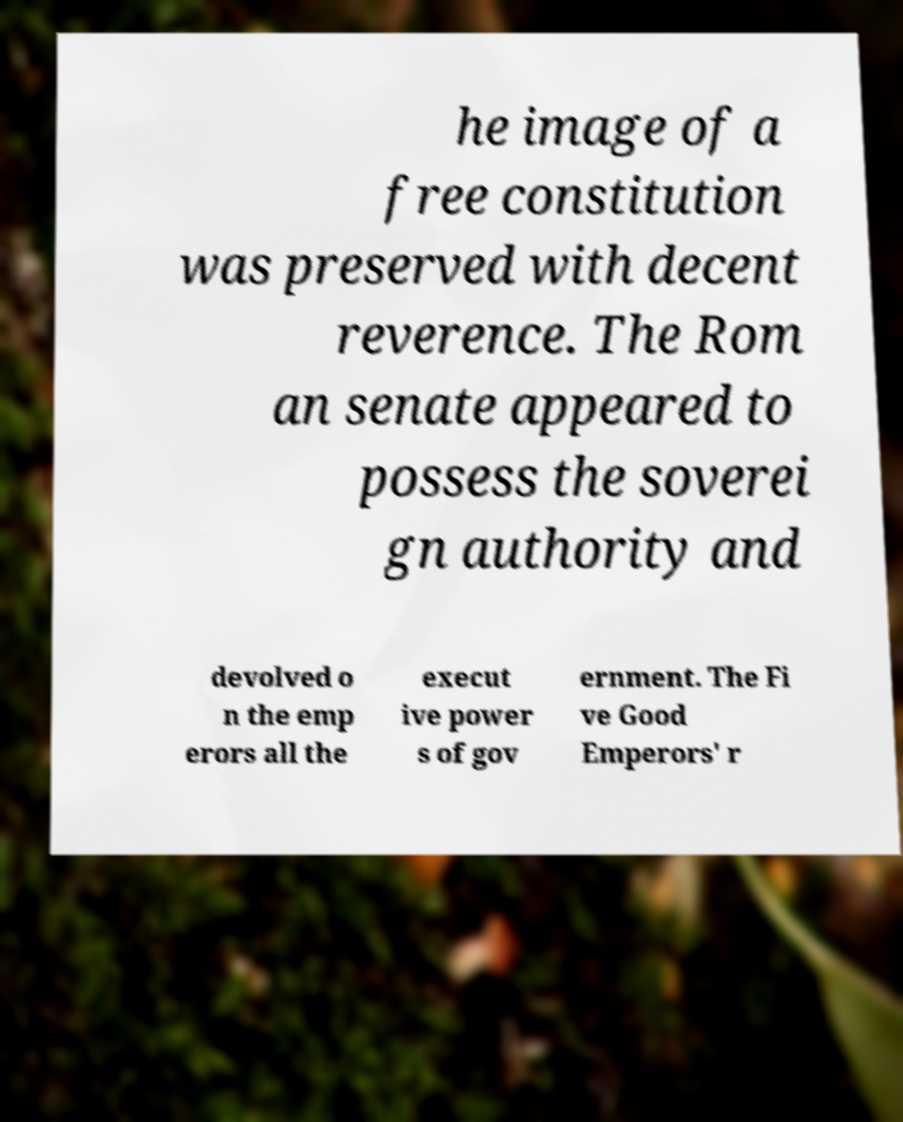Please read and relay the text visible in this image. What does it say? he image of a free constitution was preserved with decent reverence. The Rom an senate appeared to possess the soverei gn authority and devolved o n the emp erors all the execut ive power s of gov ernment. The Fi ve Good Emperors' r 